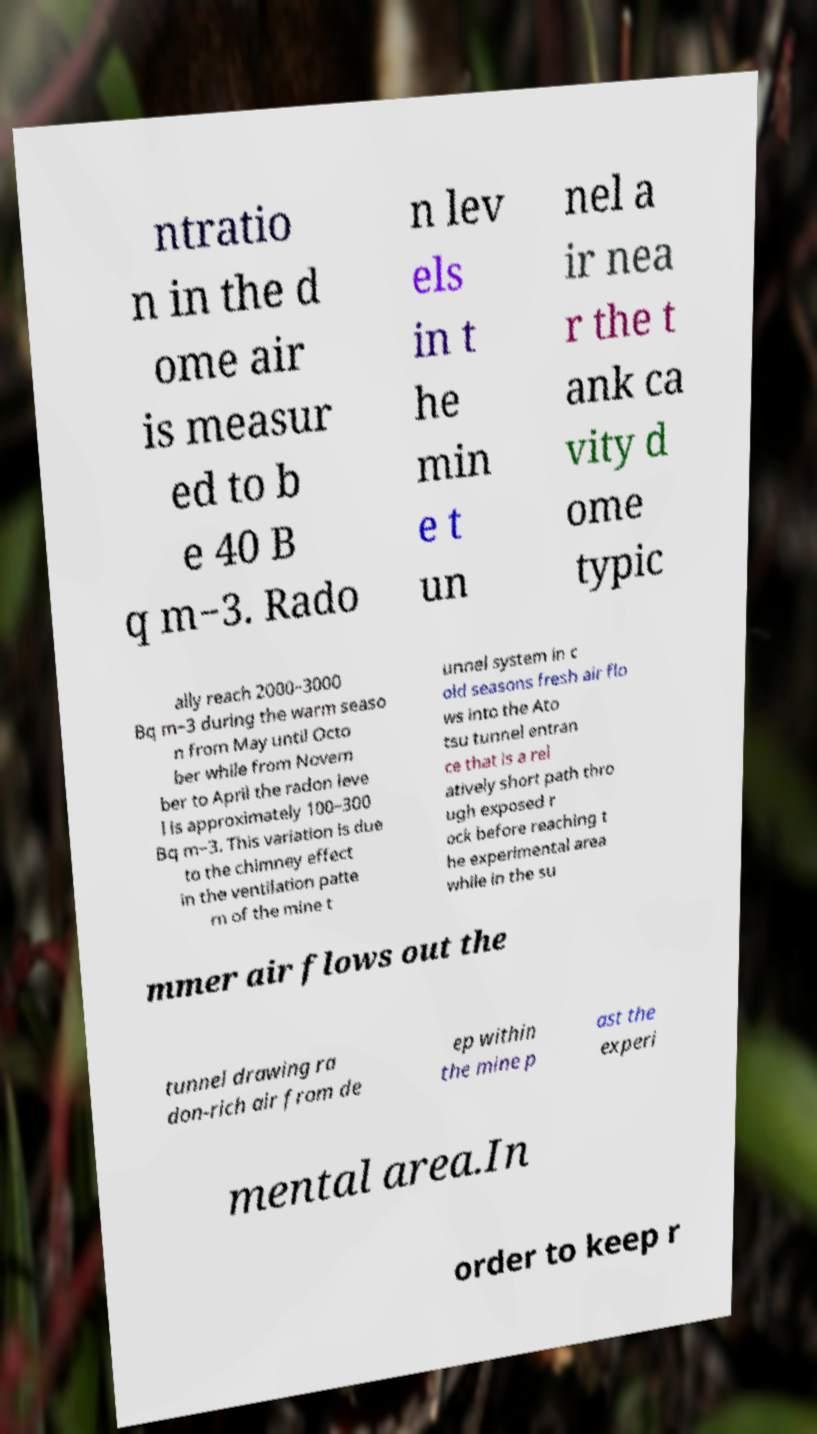I need the written content from this picture converted into text. Can you do that? ntratio n in the d ome air is measur ed to b e 40 B q m−3. Rado n lev els in t he min e t un nel a ir nea r the t ank ca vity d ome typic ally reach 2000–3000 Bq m−3 during the warm seaso n from May until Octo ber while from Novem ber to April the radon leve l is approximately 100–300 Bq m−3. This variation is due to the chimney effect in the ventilation patte rn of the mine t unnel system in c old seasons fresh air flo ws into the Ato tsu tunnel entran ce that is a rel atively short path thro ugh exposed r ock before reaching t he experimental area while in the su mmer air flows out the tunnel drawing ra don-rich air from de ep within the mine p ast the experi mental area.In order to keep r 